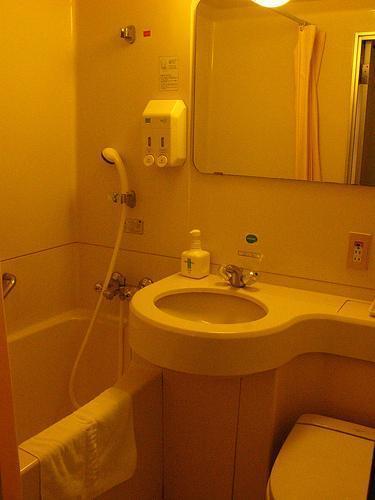How many towels can be seen?
Give a very brief answer. 1. How many floor mats are on the edge of the tub?
Give a very brief answer. 1. 